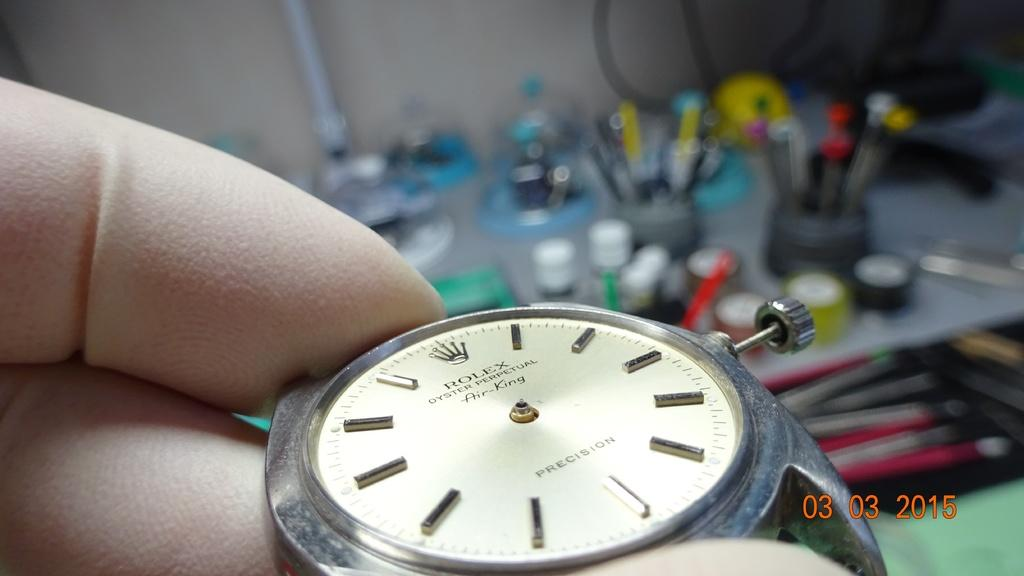<image>
Describe the image concisely. A person is repairing a Rolex watch in 2015. 